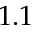Convert formula to latex. <formula><loc_0><loc_0><loc_500><loc_500>1 . 1</formula> 